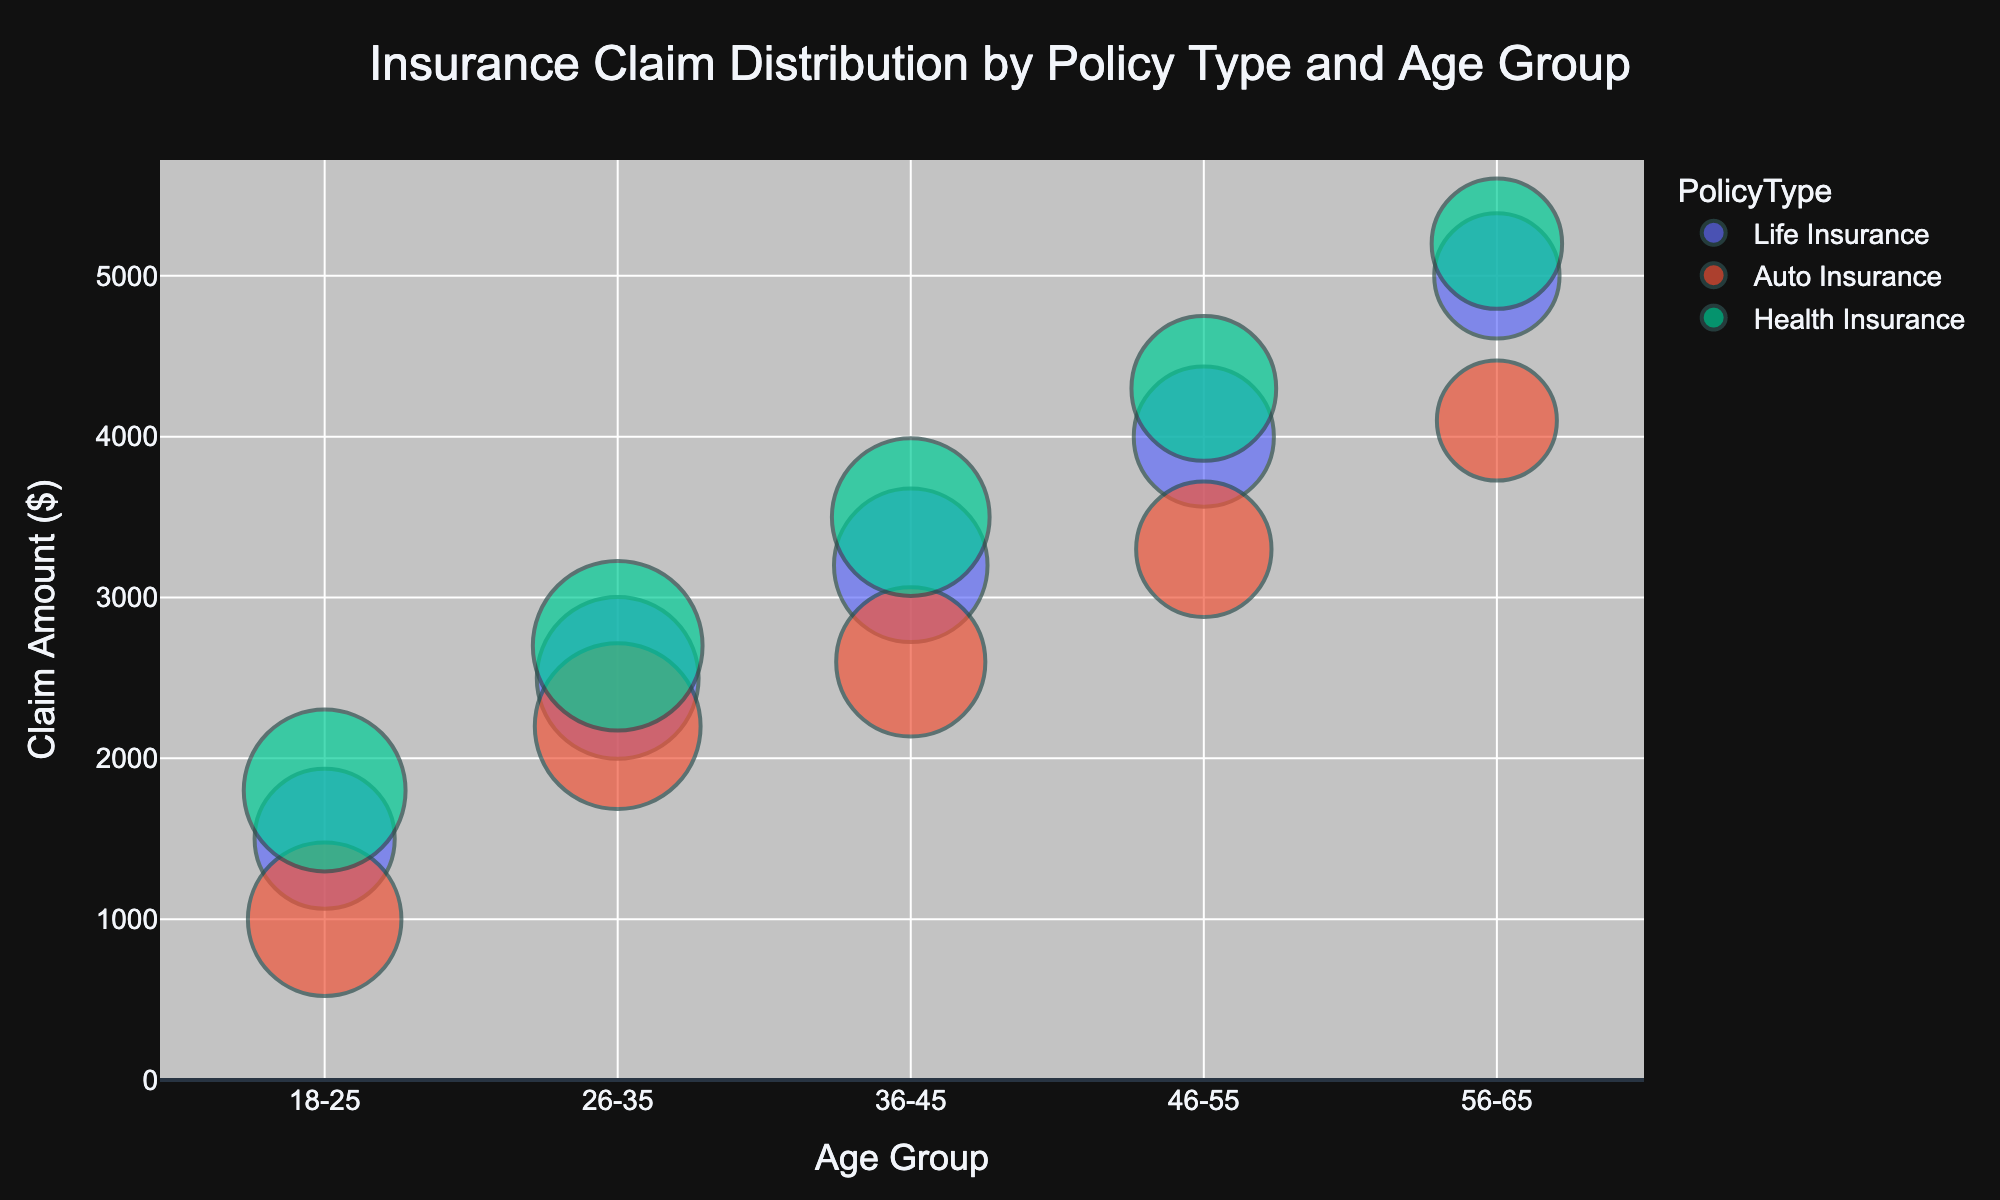How many age groups are represented in the plot? To determine how many age groups are represented, count the unique age group labels on the x-axis.
Answer: 5 Which policy type includes the highest claim amount for the age group 56-65? Look for the bubbles in the 56-65 age group on the x-axis and identify which one has the highest y-axis value among the different colors (policy types).
Answer: Health Insurance In the age group 18-25, which policy type has the largest population? Find the bubbles in the 18-25 age group on the x-axis, and look for the bubble with the largest size. Check its corresponding color or hover text to determine the policy type.
Answer: Health Insurance What is the difference in claim amounts between Auto Insurance and Life Insurance for the age group 36-45? Find the bubbles for Auto Insurance and Life Insurance in the 36-45 age group and subtract the claim amount of Auto Insurance from Life Insurance.
Answer: 600 Among all policy types, which one shows an increasing trend in claim amounts with age groups? Examine the vertical positions of bubbles for each policy type across different age groups. Identify the policy type for which the claim amounts consistently increase as you move from younger to older age groups.
Answer: Life Insurance Which age group and policy type have the smallest claim amount? Look for the smallest bubble along the y-axis in the entire plot, then read its corresponding age group and color/policy type.
Answer: Auto Insurance, 18-25 How does the claim amount for Health Insurance in the age group 46-55 compare to Life Insurance in the same age group? Locate the bubbles for Health Insurance and Life Insurance in the 46-55 age group and compare their vertical positions (y-axis values).
Answer: Higher What is the average claim amount for Auto Insurance across all age groups? Find all Auto Insurance bubbles, sum their claim amounts, and divide by the number of age groups. (1000 + 2200 + 2600 + 3300 + 4100) / 5 = 13200 / 5.
Answer: 2640 What is the most significant visual difference between Life Insurance and Health Insurance distributions across all demographics? Compare the bubble patterns and sizes between Life Insurance and Health Insurance across all age groups to identify the key visual difference.
Answer: Life Insurance tends to have lower claim amounts and smaller bubbles (population) than Health Insurance overall Which policy type has the most pronounced clustering of claim amounts irrespective of age group? Look for the policy type where bubbles appear to be closer together in terms of their vertical positions (y-axis values) across the whole plot.
Answer: Auto Insurance 